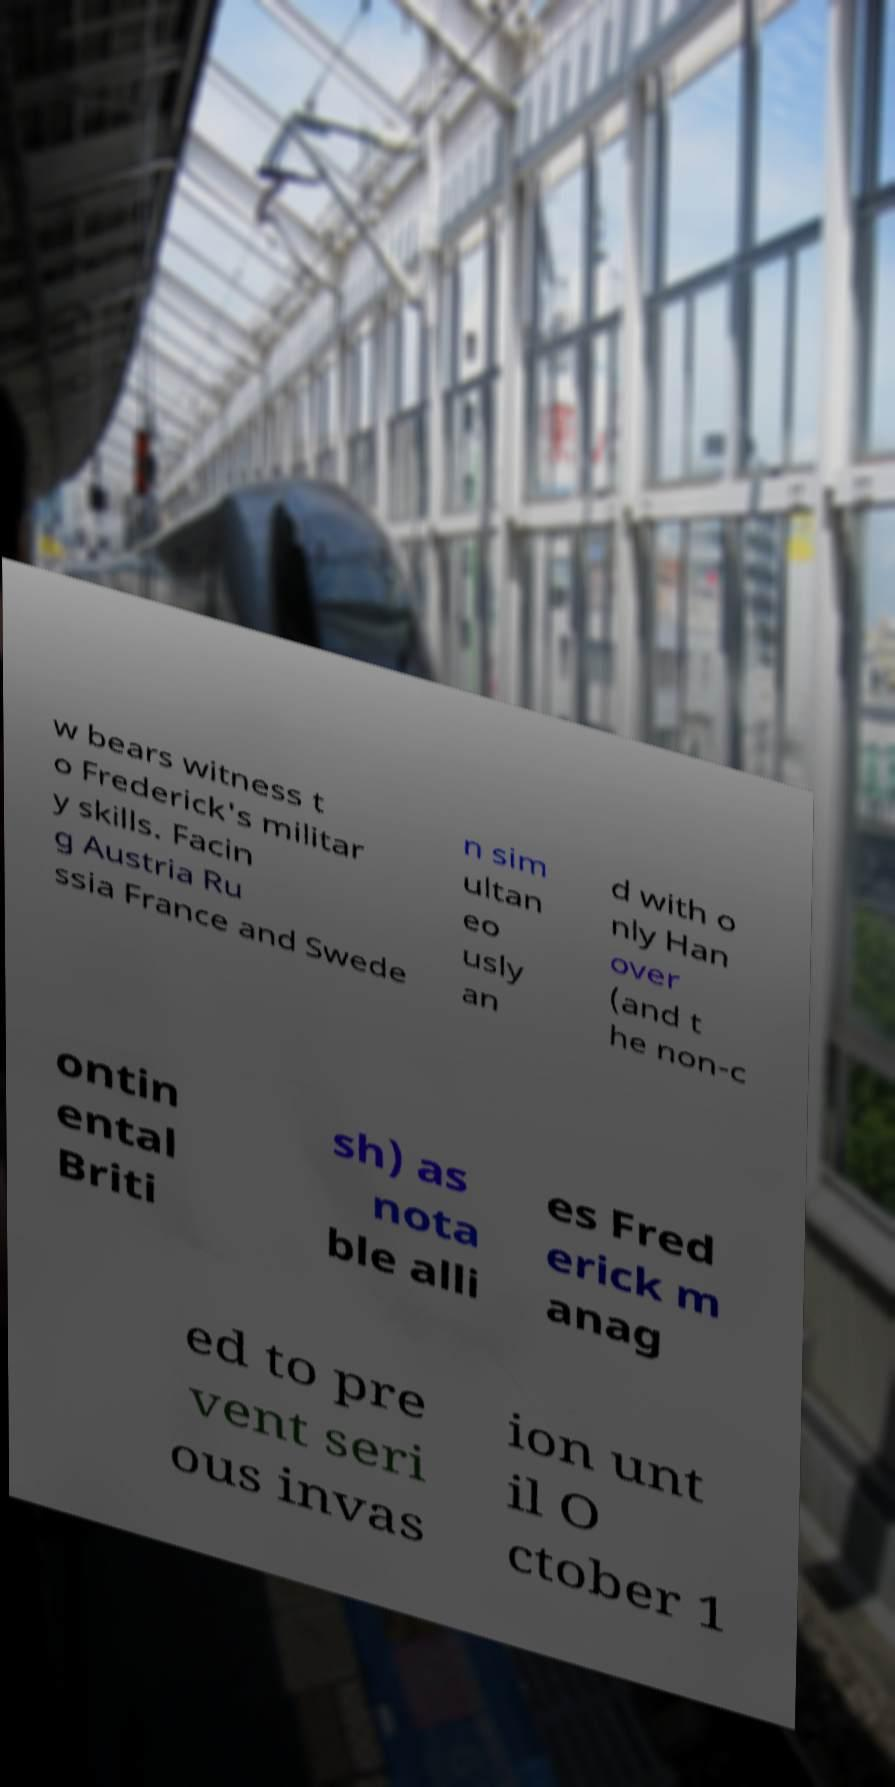Can you accurately transcribe the text from the provided image for me? w bears witness t o Frederick's militar y skills. Facin g Austria Ru ssia France and Swede n sim ultan eo usly an d with o nly Han over (and t he non-c ontin ental Briti sh) as nota ble alli es Fred erick m anag ed to pre vent seri ous invas ion unt il O ctober 1 